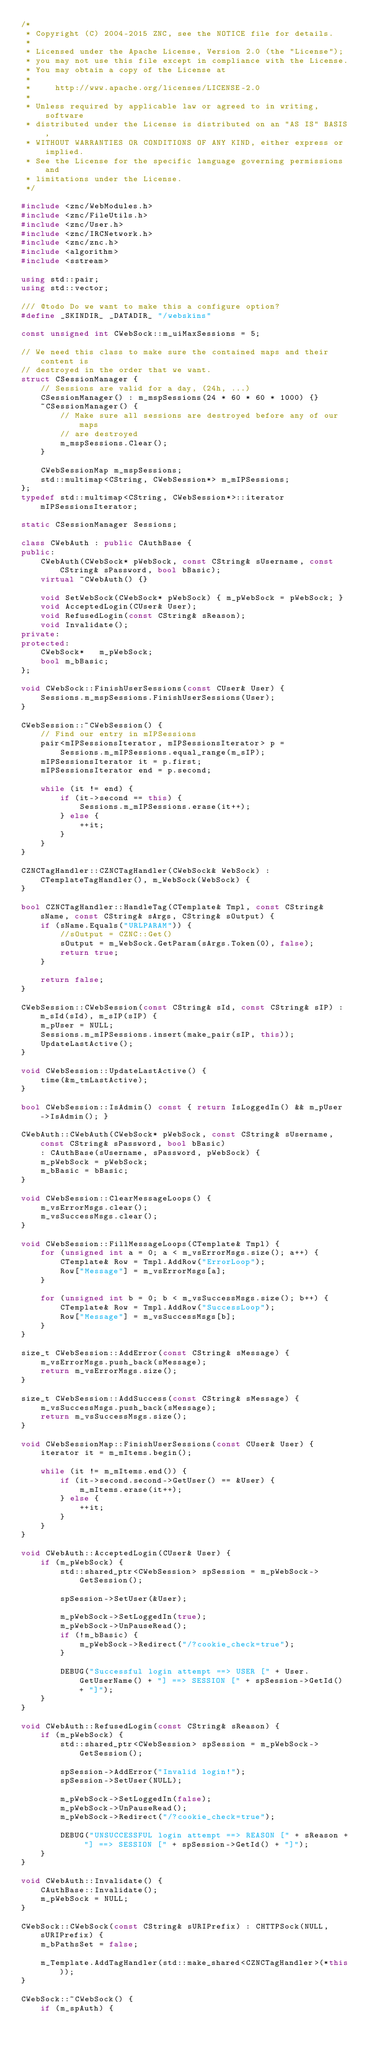<code> <loc_0><loc_0><loc_500><loc_500><_C++_>/*
 * Copyright (C) 2004-2015 ZNC, see the NOTICE file for details.
 *
 * Licensed under the Apache License, Version 2.0 (the "License");
 * you may not use this file except in compliance with the License.
 * You may obtain a copy of the License at
 *
 *     http://www.apache.org/licenses/LICENSE-2.0
 *
 * Unless required by applicable law or agreed to in writing, software
 * distributed under the License is distributed on an "AS IS" BASIS,
 * WITHOUT WARRANTIES OR CONDITIONS OF ANY KIND, either express or implied.
 * See the License for the specific language governing permissions and
 * limitations under the License.
 */

#include <znc/WebModules.h>
#include <znc/FileUtils.h>
#include <znc/User.h>
#include <znc/IRCNetwork.h>
#include <znc/znc.h>
#include <algorithm>
#include <sstream>

using std::pair;
using std::vector;

/// @todo Do we want to make this a configure option?
#define _SKINDIR_ _DATADIR_ "/webskins"

const unsigned int CWebSock::m_uiMaxSessions = 5;

// We need this class to make sure the contained maps and their content is
// destroyed in the order that we want.
struct CSessionManager {
	// Sessions are valid for a day, (24h, ...)
	CSessionManager() : m_mspSessions(24 * 60 * 60 * 1000) {}
	~CSessionManager() {
		// Make sure all sessions are destroyed before any of our maps
		// are destroyed
		m_mspSessions.Clear();
	}

	CWebSessionMap m_mspSessions;
	std::multimap<CString, CWebSession*> m_mIPSessions;
};
typedef std::multimap<CString, CWebSession*>::iterator mIPSessionsIterator;

static CSessionManager Sessions;

class CWebAuth : public CAuthBase {
public:
	CWebAuth(CWebSock* pWebSock, const CString& sUsername, const CString& sPassword, bool bBasic);
	virtual ~CWebAuth() {}

	void SetWebSock(CWebSock* pWebSock) { m_pWebSock = pWebSock; }
	void AcceptedLogin(CUser& User);
	void RefusedLogin(const CString& sReason);
	void Invalidate();
private:
protected:
	CWebSock*   m_pWebSock;
	bool m_bBasic;
};

void CWebSock::FinishUserSessions(const CUser& User) {
	Sessions.m_mspSessions.FinishUserSessions(User);
}

CWebSession::~CWebSession() {
	// Find our entry in mIPSessions
	pair<mIPSessionsIterator, mIPSessionsIterator> p =
		Sessions.m_mIPSessions.equal_range(m_sIP);
	mIPSessionsIterator it = p.first;
	mIPSessionsIterator end = p.second;

	while (it != end) {
		if (it->second == this) {
			Sessions.m_mIPSessions.erase(it++);
		} else {
			++it;
		}
	}
}

CZNCTagHandler::CZNCTagHandler(CWebSock& WebSock) : CTemplateTagHandler(), m_WebSock(WebSock) {
}

bool CZNCTagHandler::HandleTag(CTemplate& Tmpl, const CString& sName, const CString& sArgs, CString& sOutput) {
	if (sName.Equals("URLPARAM")) {
		//sOutput = CZNC::Get()
		sOutput = m_WebSock.GetParam(sArgs.Token(0), false);
		return true;
	}

	return false;
}

CWebSession::CWebSession(const CString& sId, const CString& sIP) : m_sId(sId), m_sIP(sIP) {
	m_pUser = NULL;
	Sessions.m_mIPSessions.insert(make_pair(sIP, this));
	UpdateLastActive();
}

void CWebSession::UpdateLastActive() {
	time(&m_tmLastActive);
}

bool CWebSession::IsAdmin() const { return IsLoggedIn() && m_pUser->IsAdmin(); }

CWebAuth::CWebAuth(CWebSock* pWebSock, const CString& sUsername, const CString& sPassword, bool bBasic)
	: CAuthBase(sUsername, sPassword, pWebSock) {
	m_pWebSock = pWebSock;
	m_bBasic = bBasic;
}

void CWebSession::ClearMessageLoops() {
	m_vsErrorMsgs.clear();
	m_vsSuccessMsgs.clear();
}

void CWebSession::FillMessageLoops(CTemplate& Tmpl) {
	for (unsigned int a = 0; a < m_vsErrorMsgs.size(); a++) {
		CTemplate& Row = Tmpl.AddRow("ErrorLoop");
		Row["Message"] = m_vsErrorMsgs[a];
	}

	for (unsigned int b = 0; b < m_vsSuccessMsgs.size(); b++) {
		CTemplate& Row = Tmpl.AddRow("SuccessLoop");
		Row["Message"] = m_vsSuccessMsgs[b];
	}
}

size_t CWebSession::AddError(const CString& sMessage) {
	m_vsErrorMsgs.push_back(sMessage);
	return m_vsErrorMsgs.size();
}

size_t CWebSession::AddSuccess(const CString& sMessage) {
	m_vsSuccessMsgs.push_back(sMessage);
	return m_vsSuccessMsgs.size();
}

void CWebSessionMap::FinishUserSessions(const CUser& User) {
	iterator it = m_mItems.begin();

	while (it != m_mItems.end()) {
		if (it->second.second->GetUser() == &User) {
			m_mItems.erase(it++);
		} else {
			++it;
		}
	}
}

void CWebAuth::AcceptedLogin(CUser& User) {
	if (m_pWebSock) {
		std::shared_ptr<CWebSession> spSession = m_pWebSock->GetSession();

		spSession->SetUser(&User);

		m_pWebSock->SetLoggedIn(true);
		m_pWebSock->UnPauseRead();
		if (!m_bBasic) {
			m_pWebSock->Redirect("/?cookie_check=true");
		}

		DEBUG("Successful login attempt ==> USER [" + User.GetUserName() + "] ==> SESSION [" + spSession->GetId() + "]");
	}
}

void CWebAuth::RefusedLogin(const CString& sReason) {
	if (m_pWebSock) {
		std::shared_ptr<CWebSession> spSession = m_pWebSock->GetSession();

		spSession->AddError("Invalid login!");
		spSession->SetUser(NULL);

		m_pWebSock->SetLoggedIn(false);
		m_pWebSock->UnPauseRead();
		m_pWebSock->Redirect("/?cookie_check=true");

		DEBUG("UNSUCCESSFUL login attempt ==> REASON [" + sReason + "] ==> SESSION [" + spSession->GetId() + "]");
	}
}

void CWebAuth::Invalidate() {
	CAuthBase::Invalidate();
	m_pWebSock = NULL;
}

CWebSock::CWebSock(const CString& sURIPrefix) : CHTTPSock(NULL, sURIPrefix) {
	m_bPathsSet = false;

	m_Template.AddTagHandler(std::make_shared<CZNCTagHandler>(*this));
}

CWebSock::~CWebSock() {
	if (m_spAuth) {</code> 